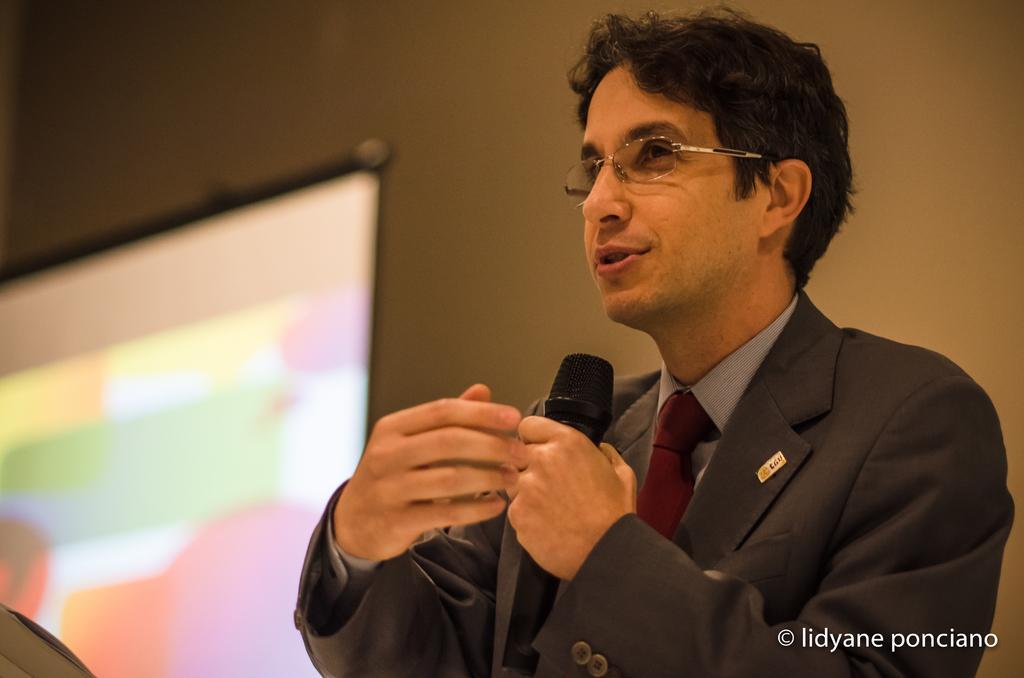How would you summarize this image in a sentence or two? On the right side of the image we can see a man standing and holding a mic in his hand. On the left there is a screen. In the background there is a wall. 